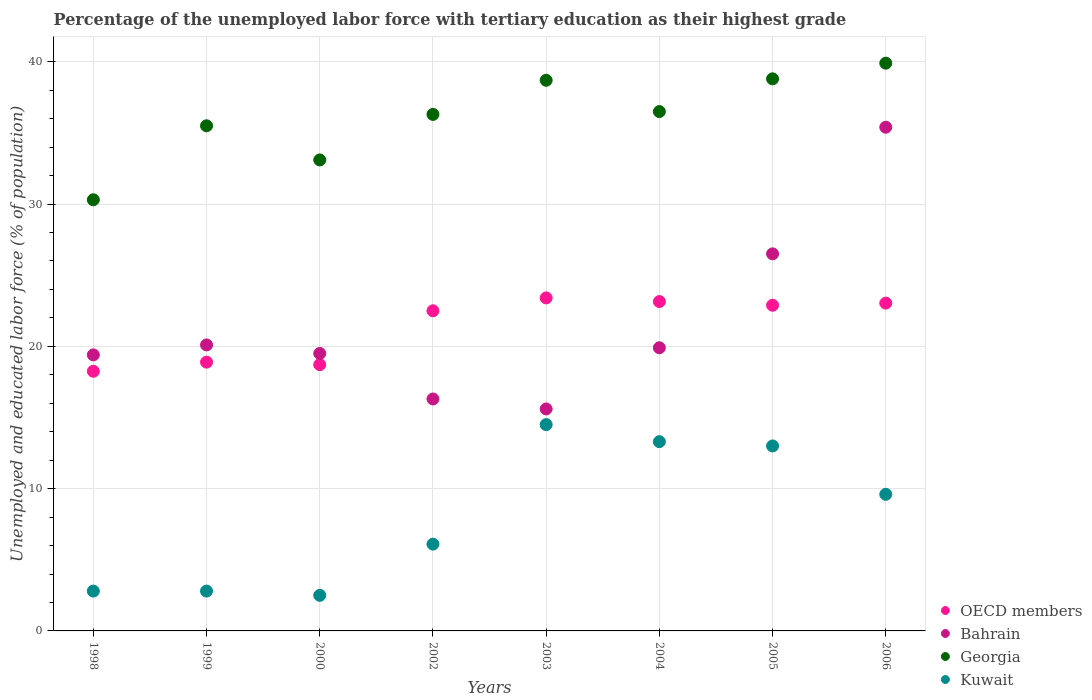How many different coloured dotlines are there?
Keep it short and to the point. 4. Is the number of dotlines equal to the number of legend labels?
Offer a very short reply. Yes. What is the percentage of the unemployed labor force with tertiary education in Georgia in 2005?
Provide a short and direct response. 38.8. Across all years, what is the maximum percentage of the unemployed labor force with tertiary education in Georgia?
Provide a short and direct response. 39.9. Across all years, what is the minimum percentage of the unemployed labor force with tertiary education in OECD members?
Ensure brevity in your answer.  18.25. In which year was the percentage of the unemployed labor force with tertiary education in Georgia minimum?
Your answer should be compact. 1998. What is the total percentage of the unemployed labor force with tertiary education in Georgia in the graph?
Keep it short and to the point. 289.1. What is the difference between the percentage of the unemployed labor force with tertiary education in Georgia in 2002 and that in 2006?
Ensure brevity in your answer.  -3.6. What is the difference between the percentage of the unemployed labor force with tertiary education in Georgia in 2003 and the percentage of the unemployed labor force with tertiary education in Bahrain in 1999?
Provide a succinct answer. 18.6. What is the average percentage of the unemployed labor force with tertiary education in Bahrain per year?
Offer a terse response. 21.59. In the year 2000, what is the difference between the percentage of the unemployed labor force with tertiary education in Kuwait and percentage of the unemployed labor force with tertiary education in Georgia?
Your answer should be compact. -30.6. In how many years, is the percentage of the unemployed labor force with tertiary education in Bahrain greater than 8 %?
Your response must be concise. 8. What is the ratio of the percentage of the unemployed labor force with tertiary education in Georgia in 1998 to that in 2002?
Your response must be concise. 0.83. Is the difference between the percentage of the unemployed labor force with tertiary education in Kuwait in 1998 and 2004 greater than the difference between the percentage of the unemployed labor force with tertiary education in Georgia in 1998 and 2004?
Provide a short and direct response. No. What is the difference between the highest and the second highest percentage of the unemployed labor force with tertiary education in Georgia?
Offer a very short reply. 1.1. What is the difference between the highest and the lowest percentage of the unemployed labor force with tertiary education in Kuwait?
Your answer should be compact. 12. In how many years, is the percentage of the unemployed labor force with tertiary education in Bahrain greater than the average percentage of the unemployed labor force with tertiary education in Bahrain taken over all years?
Your answer should be very brief. 2. Is it the case that in every year, the sum of the percentage of the unemployed labor force with tertiary education in OECD members and percentage of the unemployed labor force with tertiary education in Kuwait  is greater than the sum of percentage of the unemployed labor force with tertiary education in Bahrain and percentage of the unemployed labor force with tertiary education in Georgia?
Provide a succinct answer. No. Is it the case that in every year, the sum of the percentage of the unemployed labor force with tertiary education in Georgia and percentage of the unemployed labor force with tertiary education in Kuwait  is greater than the percentage of the unemployed labor force with tertiary education in OECD members?
Offer a terse response. Yes. Does the percentage of the unemployed labor force with tertiary education in Georgia monotonically increase over the years?
Make the answer very short. No. Where does the legend appear in the graph?
Provide a short and direct response. Bottom right. How many legend labels are there?
Make the answer very short. 4. What is the title of the graph?
Your answer should be very brief. Percentage of the unemployed labor force with tertiary education as their highest grade. What is the label or title of the X-axis?
Offer a terse response. Years. What is the label or title of the Y-axis?
Ensure brevity in your answer.  Unemployed and educated labor force (% of population). What is the Unemployed and educated labor force (% of population) of OECD members in 1998?
Offer a terse response. 18.25. What is the Unemployed and educated labor force (% of population) of Bahrain in 1998?
Provide a succinct answer. 19.4. What is the Unemployed and educated labor force (% of population) of Georgia in 1998?
Offer a very short reply. 30.3. What is the Unemployed and educated labor force (% of population) of Kuwait in 1998?
Your response must be concise. 2.8. What is the Unemployed and educated labor force (% of population) of OECD members in 1999?
Offer a very short reply. 18.89. What is the Unemployed and educated labor force (% of population) in Bahrain in 1999?
Give a very brief answer. 20.1. What is the Unemployed and educated labor force (% of population) in Georgia in 1999?
Provide a succinct answer. 35.5. What is the Unemployed and educated labor force (% of population) in Kuwait in 1999?
Your response must be concise. 2.8. What is the Unemployed and educated labor force (% of population) in OECD members in 2000?
Offer a terse response. 18.71. What is the Unemployed and educated labor force (% of population) in Bahrain in 2000?
Offer a very short reply. 19.5. What is the Unemployed and educated labor force (% of population) in Georgia in 2000?
Provide a succinct answer. 33.1. What is the Unemployed and educated labor force (% of population) in OECD members in 2002?
Offer a very short reply. 22.5. What is the Unemployed and educated labor force (% of population) of Bahrain in 2002?
Your answer should be compact. 16.3. What is the Unemployed and educated labor force (% of population) of Georgia in 2002?
Give a very brief answer. 36.3. What is the Unemployed and educated labor force (% of population) of Kuwait in 2002?
Keep it short and to the point. 6.1. What is the Unemployed and educated labor force (% of population) of OECD members in 2003?
Keep it short and to the point. 23.4. What is the Unemployed and educated labor force (% of population) of Bahrain in 2003?
Provide a succinct answer. 15.6. What is the Unemployed and educated labor force (% of population) in Georgia in 2003?
Your response must be concise. 38.7. What is the Unemployed and educated labor force (% of population) of Kuwait in 2003?
Make the answer very short. 14.5. What is the Unemployed and educated labor force (% of population) of OECD members in 2004?
Keep it short and to the point. 23.15. What is the Unemployed and educated labor force (% of population) of Bahrain in 2004?
Your answer should be very brief. 19.9. What is the Unemployed and educated labor force (% of population) in Georgia in 2004?
Your answer should be very brief. 36.5. What is the Unemployed and educated labor force (% of population) of Kuwait in 2004?
Ensure brevity in your answer.  13.3. What is the Unemployed and educated labor force (% of population) of OECD members in 2005?
Your response must be concise. 22.89. What is the Unemployed and educated labor force (% of population) in Georgia in 2005?
Give a very brief answer. 38.8. What is the Unemployed and educated labor force (% of population) of Kuwait in 2005?
Give a very brief answer. 13. What is the Unemployed and educated labor force (% of population) in OECD members in 2006?
Provide a succinct answer. 23.04. What is the Unemployed and educated labor force (% of population) of Bahrain in 2006?
Your answer should be compact. 35.4. What is the Unemployed and educated labor force (% of population) in Georgia in 2006?
Ensure brevity in your answer.  39.9. What is the Unemployed and educated labor force (% of population) in Kuwait in 2006?
Your response must be concise. 9.6. Across all years, what is the maximum Unemployed and educated labor force (% of population) of OECD members?
Your answer should be compact. 23.4. Across all years, what is the maximum Unemployed and educated labor force (% of population) in Bahrain?
Ensure brevity in your answer.  35.4. Across all years, what is the maximum Unemployed and educated labor force (% of population) in Georgia?
Provide a succinct answer. 39.9. Across all years, what is the maximum Unemployed and educated labor force (% of population) of Kuwait?
Make the answer very short. 14.5. Across all years, what is the minimum Unemployed and educated labor force (% of population) of OECD members?
Your answer should be very brief. 18.25. Across all years, what is the minimum Unemployed and educated labor force (% of population) in Bahrain?
Your response must be concise. 15.6. Across all years, what is the minimum Unemployed and educated labor force (% of population) of Georgia?
Give a very brief answer. 30.3. Across all years, what is the minimum Unemployed and educated labor force (% of population) in Kuwait?
Offer a very short reply. 2.5. What is the total Unemployed and educated labor force (% of population) of OECD members in the graph?
Offer a very short reply. 170.83. What is the total Unemployed and educated labor force (% of population) of Bahrain in the graph?
Offer a terse response. 172.7. What is the total Unemployed and educated labor force (% of population) of Georgia in the graph?
Keep it short and to the point. 289.1. What is the total Unemployed and educated labor force (% of population) in Kuwait in the graph?
Make the answer very short. 64.6. What is the difference between the Unemployed and educated labor force (% of population) in OECD members in 1998 and that in 1999?
Your response must be concise. -0.64. What is the difference between the Unemployed and educated labor force (% of population) in Bahrain in 1998 and that in 1999?
Provide a short and direct response. -0.7. What is the difference between the Unemployed and educated labor force (% of population) of Kuwait in 1998 and that in 1999?
Offer a terse response. 0. What is the difference between the Unemployed and educated labor force (% of population) in OECD members in 1998 and that in 2000?
Make the answer very short. -0.47. What is the difference between the Unemployed and educated labor force (% of population) in Bahrain in 1998 and that in 2000?
Your answer should be very brief. -0.1. What is the difference between the Unemployed and educated labor force (% of population) in OECD members in 1998 and that in 2002?
Keep it short and to the point. -4.25. What is the difference between the Unemployed and educated labor force (% of population) of Georgia in 1998 and that in 2002?
Ensure brevity in your answer.  -6. What is the difference between the Unemployed and educated labor force (% of population) of Kuwait in 1998 and that in 2002?
Your answer should be compact. -3.3. What is the difference between the Unemployed and educated labor force (% of population) of OECD members in 1998 and that in 2003?
Give a very brief answer. -5.16. What is the difference between the Unemployed and educated labor force (% of population) in Bahrain in 1998 and that in 2003?
Your response must be concise. 3.8. What is the difference between the Unemployed and educated labor force (% of population) in OECD members in 1998 and that in 2004?
Offer a very short reply. -4.9. What is the difference between the Unemployed and educated labor force (% of population) in Bahrain in 1998 and that in 2004?
Offer a very short reply. -0.5. What is the difference between the Unemployed and educated labor force (% of population) of OECD members in 1998 and that in 2005?
Provide a succinct answer. -4.64. What is the difference between the Unemployed and educated labor force (% of population) of Bahrain in 1998 and that in 2005?
Your response must be concise. -7.1. What is the difference between the Unemployed and educated labor force (% of population) of Georgia in 1998 and that in 2005?
Ensure brevity in your answer.  -8.5. What is the difference between the Unemployed and educated labor force (% of population) in Kuwait in 1998 and that in 2005?
Provide a succinct answer. -10.2. What is the difference between the Unemployed and educated labor force (% of population) in OECD members in 1998 and that in 2006?
Provide a succinct answer. -4.79. What is the difference between the Unemployed and educated labor force (% of population) in Georgia in 1998 and that in 2006?
Provide a short and direct response. -9.6. What is the difference between the Unemployed and educated labor force (% of population) in OECD members in 1999 and that in 2000?
Provide a short and direct response. 0.17. What is the difference between the Unemployed and educated labor force (% of population) in OECD members in 1999 and that in 2002?
Ensure brevity in your answer.  -3.61. What is the difference between the Unemployed and educated labor force (% of population) in Georgia in 1999 and that in 2002?
Keep it short and to the point. -0.8. What is the difference between the Unemployed and educated labor force (% of population) of OECD members in 1999 and that in 2003?
Offer a terse response. -4.51. What is the difference between the Unemployed and educated labor force (% of population) of OECD members in 1999 and that in 2004?
Provide a short and direct response. -4.26. What is the difference between the Unemployed and educated labor force (% of population) of Bahrain in 1999 and that in 2004?
Offer a very short reply. 0.2. What is the difference between the Unemployed and educated labor force (% of population) in OECD members in 1999 and that in 2005?
Make the answer very short. -4. What is the difference between the Unemployed and educated labor force (% of population) of Georgia in 1999 and that in 2005?
Your response must be concise. -3.3. What is the difference between the Unemployed and educated labor force (% of population) in OECD members in 1999 and that in 2006?
Offer a terse response. -4.15. What is the difference between the Unemployed and educated labor force (% of population) in Bahrain in 1999 and that in 2006?
Give a very brief answer. -15.3. What is the difference between the Unemployed and educated labor force (% of population) in Kuwait in 1999 and that in 2006?
Your answer should be very brief. -6.8. What is the difference between the Unemployed and educated labor force (% of population) in OECD members in 2000 and that in 2002?
Your answer should be very brief. -3.78. What is the difference between the Unemployed and educated labor force (% of population) in Georgia in 2000 and that in 2002?
Offer a terse response. -3.2. What is the difference between the Unemployed and educated labor force (% of population) in OECD members in 2000 and that in 2003?
Keep it short and to the point. -4.69. What is the difference between the Unemployed and educated labor force (% of population) in Georgia in 2000 and that in 2003?
Provide a short and direct response. -5.6. What is the difference between the Unemployed and educated labor force (% of population) of OECD members in 2000 and that in 2004?
Provide a short and direct response. -4.43. What is the difference between the Unemployed and educated labor force (% of population) of Kuwait in 2000 and that in 2004?
Ensure brevity in your answer.  -10.8. What is the difference between the Unemployed and educated labor force (% of population) in OECD members in 2000 and that in 2005?
Provide a short and direct response. -4.17. What is the difference between the Unemployed and educated labor force (% of population) of Bahrain in 2000 and that in 2005?
Keep it short and to the point. -7. What is the difference between the Unemployed and educated labor force (% of population) in Kuwait in 2000 and that in 2005?
Your answer should be very brief. -10.5. What is the difference between the Unemployed and educated labor force (% of population) of OECD members in 2000 and that in 2006?
Keep it short and to the point. -4.32. What is the difference between the Unemployed and educated labor force (% of population) in Bahrain in 2000 and that in 2006?
Ensure brevity in your answer.  -15.9. What is the difference between the Unemployed and educated labor force (% of population) of Georgia in 2000 and that in 2006?
Offer a very short reply. -6.8. What is the difference between the Unemployed and educated labor force (% of population) in Kuwait in 2000 and that in 2006?
Make the answer very short. -7.1. What is the difference between the Unemployed and educated labor force (% of population) in OECD members in 2002 and that in 2003?
Offer a terse response. -0.91. What is the difference between the Unemployed and educated labor force (% of population) of Bahrain in 2002 and that in 2003?
Make the answer very short. 0.7. What is the difference between the Unemployed and educated labor force (% of population) of Georgia in 2002 and that in 2003?
Offer a very short reply. -2.4. What is the difference between the Unemployed and educated labor force (% of population) in OECD members in 2002 and that in 2004?
Your answer should be very brief. -0.65. What is the difference between the Unemployed and educated labor force (% of population) of Bahrain in 2002 and that in 2004?
Your response must be concise. -3.6. What is the difference between the Unemployed and educated labor force (% of population) of Kuwait in 2002 and that in 2004?
Your answer should be very brief. -7.2. What is the difference between the Unemployed and educated labor force (% of population) of OECD members in 2002 and that in 2005?
Your answer should be compact. -0.39. What is the difference between the Unemployed and educated labor force (% of population) of Bahrain in 2002 and that in 2005?
Ensure brevity in your answer.  -10.2. What is the difference between the Unemployed and educated labor force (% of population) of Kuwait in 2002 and that in 2005?
Provide a succinct answer. -6.9. What is the difference between the Unemployed and educated labor force (% of population) of OECD members in 2002 and that in 2006?
Offer a very short reply. -0.54. What is the difference between the Unemployed and educated labor force (% of population) in Bahrain in 2002 and that in 2006?
Offer a very short reply. -19.1. What is the difference between the Unemployed and educated labor force (% of population) in OECD members in 2003 and that in 2004?
Your response must be concise. 0.26. What is the difference between the Unemployed and educated labor force (% of population) in Bahrain in 2003 and that in 2004?
Keep it short and to the point. -4.3. What is the difference between the Unemployed and educated labor force (% of population) in Georgia in 2003 and that in 2004?
Offer a very short reply. 2.2. What is the difference between the Unemployed and educated labor force (% of population) in Kuwait in 2003 and that in 2004?
Provide a short and direct response. 1.2. What is the difference between the Unemployed and educated labor force (% of population) of OECD members in 2003 and that in 2005?
Your answer should be compact. 0.52. What is the difference between the Unemployed and educated labor force (% of population) of Kuwait in 2003 and that in 2005?
Provide a succinct answer. 1.5. What is the difference between the Unemployed and educated labor force (% of population) in OECD members in 2003 and that in 2006?
Your answer should be compact. 0.37. What is the difference between the Unemployed and educated labor force (% of population) of Bahrain in 2003 and that in 2006?
Ensure brevity in your answer.  -19.8. What is the difference between the Unemployed and educated labor force (% of population) of OECD members in 2004 and that in 2005?
Give a very brief answer. 0.26. What is the difference between the Unemployed and educated labor force (% of population) in Georgia in 2004 and that in 2005?
Provide a short and direct response. -2.3. What is the difference between the Unemployed and educated labor force (% of population) of OECD members in 2004 and that in 2006?
Your answer should be compact. 0.11. What is the difference between the Unemployed and educated labor force (% of population) of Bahrain in 2004 and that in 2006?
Your answer should be compact. -15.5. What is the difference between the Unemployed and educated labor force (% of population) in OECD members in 2005 and that in 2006?
Make the answer very short. -0.15. What is the difference between the Unemployed and educated labor force (% of population) of Bahrain in 2005 and that in 2006?
Give a very brief answer. -8.9. What is the difference between the Unemployed and educated labor force (% of population) of Georgia in 2005 and that in 2006?
Provide a succinct answer. -1.1. What is the difference between the Unemployed and educated labor force (% of population) of OECD members in 1998 and the Unemployed and educated labor force (% of population) of Bahrain in 1999?
Your answer should be very brief. -1.85. What is the difference between the Unemployed and educated labor force (% of population) of OECD members in 1998 and the Unemployed and educated labor force (% of population) of Georgia in 1999?
Keep it short and to the point. -17.25. What is the difference between the Unemployed and educated labor force (% of population) in OECD members in 1998 and the Unemployed and educated labor force (% of population) in Kuwait in 1999?
Offer a terse response. 15.45. What is the difference between the Unemployed and educated labor force (% of population) in Bahrain in 1998 and the Unemployed and educated labor force (% of population) in Georgia in 1999?
Your answer should be compact. -16.1. What is the difference between the Unemployed and educated labor force (% of population) in OECD members in 1998 and the Unemployed and educated labor force (% of population) in Bahrain in 2000?
Make the answer very short. -1.25. What is the difference between the Unemployed and educated labor force (% of population) of OECD members in 1998 and the Unemployed and educated labor force (% of population) of Georgia in 2000?
Your response must be concise. -14.85. What is the difference between the Unemployed and educated labor force (% of population) of OECD members in 1998 and the Unemployed and educated labor force (% of population) of Kuwait in 2000?
Keep it short and to the point. 15.75. What is the difference between the Unemployed and educated labor force (% of population) of Bahrain in 1998 and the Unemployed and educated labor force (% of population) of Georgia in 2000?
Provide a short and direct response. -13.7. What is the difference between the Unemployed and educated labor force (% of population) of Georgia in 1998 and the Unemployed and educated labor force (% of population) of Kuwait in 2000?
Offer a very short reply. 27.8. What is the difference between the Unemployed and educated labor force (% of population) of OECD members in 1998 and the Unemployed and educated labor force (% of population) of Bahrain in 2002?
Make the answer very short. 1.95. What is the difference between the Unemployed and educated labor force (% of population) of OECD members in 1998 and the Unemployed and educated labor force (% of population) of Georgia in 2002?
Ensure brevity in your answer.  -18.05. What is the difference between the Unemployed and educated labor force (% of population) in OECD members in 1998 and the Unemployed and educated labor force (% of population) in Kuwait in 2002?
Keep it short and to the point. 12.15. What is the difference between the Unemployed and educated labor force (% of population) of Bahrain in 1998 and the Unemployed and educated labor force (% of population) of Georgia in 2002?
Provide a short and direct response. -16.9. What is the difference between the Unemployed and educated labor force (% of population) in Georgia in 1998 and the Unemployed and educated labor force (% of population) in Kuwait in 2002?
Offer a terse response. 24.2. What is the difference between the Unemployed and educated labor force (% of population) in OECD members in 1998 and the Unemployed and educated labor force (% of population) in Bahrain in 2003?
Your response must be concise. 2.65. What is the difference between the Unemployed and educated labor force (% of population) in OECD members in 1998 and the Unemployed and educated labor force (% of population) in Georgia in 2003?
Keep it short and to the point. -20.45. What is the difference between the Unemployed and educated labor force (% of population) of OECD members in 1998 and the Unemployed and educated labor force (% of population) of Kuwait in 2003?
Give a very brief answer. 3.75. What is the difference between the Unemployed and educated labor force (% of population) in Bahrain in 1998 and the Unemployed and educated labor force (% of population) in Georgia in 2003?
Give a very brief answer. -19.3. What is the difference between the Unemployed and educated labor force (% of population) of OECD members in 1998 and the Unemployed and educated labor force (% of population) of Bahrain in 2004?
Your response must be concise. -1.65. What is the difference between the Unemployed and educated labor force (% of population) of OECD members in 1998 and the Unemployed and educated labor force (% of population) of Georgia in 2004?
Provide a succinct answer. -18.25. What is the difference between the Unemployed and educated labor force (% of population) in OECD members in 1998 and the Unemployed and educated labor force (% of population) in Kuwait in 2004?
Give a very brief answer. 4.95. What is the difference between the Unemployed and educated labor force (% of population) of Bahrain in 1998 and the Unemployed and educated labor force (% of population) of Georgia in 2004?
Offer a very short reply. -17.1. What is the difference between the Unemployed and educated labor force (% of population) of Bahrain in 1998 and the Unemployed and educated labor force (% of population) of Kuwait in 2004?
Make the answer very short. 6.1. What is the difference between the Unemployed and educated labor force (% of population) in Georgia in 1998 and the Unemployed and educated labor force (% of population) in Kuwait in 2004?
Make the answer very short. 17. What is the difference between the Unemployed and educated labor force (% of population) in OECD members in 1998 and the Unemployed and educated labor force (% of population) in Bahrain in 2005?
Offer a very short reply. -8.25. What is the difference between the Unemployed and educated labor force (% of population) of OECD members in 1998 and the Unemployed and educated labor force (% of population) of Georgia in 2005?
Offer a very short reply. -20.55. What is the difference between the Unemployed and educated labor force (% of population) of OECD members in 1998 and the Unemployed and educated labor force (% of population) of Kuwait in 2005?
Offer a very short reply. 5.25. What is the difference between the Unemployed and educated labor force (% of population) in Bahrain in 1998 and the Unemployed and educated labor force (% of population) in Georgia in 2005?
Your answer should be compact. -19.4. What is the difference between the Unemployed and educated labor force (% of population) in OECD members in 1998 and the Unemployed and educated labor force (% of population) in Bahrain in 2006?
Your response must be concise. -17.15. What is the difference between the Unemployed and educated labor force (% of population) of OECD members in 1998 and the Unemployed and educated labor force (% of population) of Georgia in 2006?
Your answer should be very brief. -21.65. What is the difference between the Unemployed and educated labor force (% of population) of OECD members in 1998 and the Unemployed and educated labor force (% of population) of Kuwait in 2006?
Your answer should be very brief. 8.65. What is the difference between the Unemployed and educated labor force (% of population) of Bahrain in 1998 and the Unemployed and educated labor force (% of population) of Georgia in 2006?
Offer a terse response. -20.5. What is the difference between the Unemployed and educated labor force (% of population) in Georgia in 1998 and the Unemployed and educated labor force (% of population) in Kuwait in 2006?
Keep it short and to the point. 20.7. What is the difference between the Unemployed and educated labor force (% of population) of OECD members in 1999 and the Unemployed and educated labor force (% of population) of Bahrain in 2000?
Offer a terse response. -0.61. What is the difference between the Unemployed and educated labor force (% of population) in OECD members in 1999 and the Unemployed and educated labor force (% of population) in Georgia in 2000?
Your answer should be compact. -14.21. What is the difference between the Unemployed and educated labor force (% of population) in OECD members in 1999 and the Unemployed and educated labor force (% of population) in Kuwait in 2000?
Offer a terse response. 16.39. What is the difference between the Unemployed and educated labor force (% of population) of Georgia in 1999 and the Unemployed and educated labor force (% of population) of Kuwait in 2000?
Your response must be concise. 33. What is the difference between the Unemployed and educated labor force (% of population) of OECD members in 1999 and the Unemployed and educated labor force (% of population) of Bahrain in 2002?
Ensure brevity in your answer.  2.59. What is the difference between the Unemployed and educated labor force (% of population) in OECD members in 1999 and the Unemployed and educated labor force (% of population) in Georgia in 2002?
Your answer should be very brief. -17.41. What is the difference between the Unemployed and educated labor force (% of population) of OECD members in 1999 and the Unemployed and educated labor force (% of population) of Kuwait in 2002?
Provide a succinct answer. 12.79. What is the difference between the Unemployed and educated labor force (% of population) of Bahrain in 1999 and the Unemployed and educated labor force (% of population) of Georgia in 2002?
Offer a very short reply. -16.2. What is the difference between the Unemployed and educated labor force (% of population) in Georgia in 1999 and the Unemployed and educated labor force (% of population) in Kuwait in 2002?
Your answer should be compact. 29.4. What is the difference between the Unemployed and educated labor force (% of population) of OECD members in 1999 and the Unemployed and educated labor force (% of population) of Bahrain in 2003?
Your answer should be compact. 3.29. What is the difference between the Unemployed and educated labor force (% of population) of OECD members in 1999 and the Unemployed and educated labor force (% of population) of Georgia in 2003?
Provide a short and direct response. -19.81. What is the difference between the Unemployed and educated labor force (% of population) in OECD members in 1999 and the Unemployed and educated labor force (% of population) in Kuwait in 2003?
Offer a very short reply. 4.39. What is the difference between the Unemployed and educated labor force (% of population) of Bahrain in 1999 and the Unemployed and educated labor force (% of population) of Georgia in 2003?
Make the answer very short. -18.6. What is the difference between the Unemployed and educated labor force (% of population) in Bahrain in 1999 and the Unemployed and educated labor force (% of population) in Kuwait in 2003?
Make the answer very short. 5.6. What is the difference between the Unemployed and educated labor force (% of population) in OECD members in 1999 and the Unemployed and educated labor force (% of population) in Bahrain in 2004?
Your answer should be very brief. -1.01. What is the difference between the Unemployed and educated labor force (% of population) of OECD members in 1999 and the Unemployed and educated labor force (% of population) of Georgia in 2004?
Provide a succinct answer. -17.61. What is the difference between the Unemployed and educated labor force (% of population) of OECD members in 1999 and the Unemployed and educated labor force (% of population) of Kuwait in 2004?
Provide a short and direct response. 5.59. What is the difference between the Unemployed and educated labor force (% of population) of Bahrain in 1999 and the Unemployed and educated labor force (% of population) of Georgia in 2004?
Provide a short and direct response. -16.4. What is the difference between the Unemployed and educated labor force (% of population) in OECD members in 1999 and the Unemployed and educated labor force (% of population) in Bahrain in 2005?
Offer a very short reply. -7.61. What is the difference between the Unemployed and educated labor force (% of population) of OECD members in 1999 and the Unemployed and educated labor force (% of population) of Georgia in 2005?
Provide a succinct answer. -19.91. What is the difference between the Unemployed and educated labor force (% of population) of OECD members in 1999 and the Unemployed and educated labor force (% of population) of Kuwait in 2005?
Your response must be concise. 5.89. What is the difference between the Unemployed and educated labor force (% of population) of Bahrain in 1999 and the Unemployed and educated labor force (% of population) of Georgia in 2005?
Make the answer very short. -18.7. What is the difference between the Unemployed and educated labor force (% of population) in OECD members in 1999 and the Unemployed and educated labor force (% of population) in Bahrain in 2006?
Your answer should be compact. -16.51. What is the difference between the Unemployed and educated labor force (% of population) of OECD members in 1999 and the Unemployed and educated labor force (% of population) of Georgia in 2006?
Give a very brief answer. -21.01. What is the difference between the Unemployed and educated labor force (% of population) of OECD members in 1999 and the Unemployed and educated labor force (% of population) of Kuwait in 2006?
Keep it short and to the point. 9.29. What is the difference between the Unemployed and educated labor force (% of population) in Bahrain in 1999 and the Unemployed and educated labor force (% of population) in Georgia in 2006?
Your response must be concise. -19.8. What is the difference between the Unemployed and educated labor force (% of population) in Georgia in 1999 and the Unemployed and educated labor force (% of population) in Kuwait in 2006?
Your response must be concise. 25.9. What is the difference between the Unemployed and educated labor force (% of population) in OECD members in 2000 and the Unemployed and educated labor force (% of population) in Bahrain in 2002?
Make the answer very short. 2.41. What is the difference between the Unemployed and educated labor force (% of population) in OECD members in 2000 and the Unemployed and educated labor force (% of population) in Georgia in 2002?
Provide a short and direct response. -17.59. What is the difference between the Unemployed and educated labor force (% of population) in OECD members in 2000 and the Unemployed and educated labor force (% of population) in Kuwait in 2002?
Make the answer very short. 12.61. What is the difference between the Unemployed and educated labor force (% of population) in Bahrain in 2000 and the Unemployed and educated labor force (% of population) in Georgia in 2002?
Ensure brevity in your answer.  -16.8. What is the difference between the Unemployed and educated labor force (% of population) in Bahrain in 2000 and the Unemployed and educated labor force (% of population) in Kuwait in 2002?
Your answer should be compact. 13.4. What is the difference between the Unemployed and educated labor force (% of population) of OECD members in 2000 and the Unemployed and educated labor force (% of population) of Bahrain in 2003?
Keep it short and to the point. 3.11. What is the difference between the Unemployed and educated labor force (% of population) of OECD members in 2000 and the Unemployed and educated labor force (% of population) of Georgia in 2003?
Your answer should be very brief. -19.99. What is the difference between the Unemployed and educated labor force (% of population) of OECD members in 2000 and the Unemployed and educated labor force (% of population) of Kuwait in 2003?
Your answer should be very brief. 4.21. What is the difference between the Unemployed and educated labor force (% of population) in Bahrain in 2000 and the Unemployed and educated labor force (% of population) in Georgia in 2003?
Offer a terse response. -19.2. What is the difference between the Unemployed and educated labor force (% of population) in Georgia in 2000 and the Unemployed and educated labor force (% of population) in Kuwait in 2003?
Offer a very short reply. 18.6. What is the difference between the Unemployed and educated labor force (% of population) of OECD members in 2000 and the Unemployed and educated labor force (% of population) of Bahrain in 2004?
Give a very brief answer. -1.19. What is the difference between the Unemployed and educated labor force (% of population) in OECD members in 2000 and the Unemployed and educated labor force (% of population) in Georgia in 2004?
Make the answer very short. -17.79. What is the difference between the Unemployed and educated labor force (% of population) in OECD members in 2000 and the Unemployed and educated labor force (% of population) in Kuwait in 2004?
Keep it short and to the point. 5.41. What is the difference between the Unemployed and educated labor force (% of population) in Bahrain in 2000 and the Unemployed and educated labor force (% of population) in Kuwait in 2004?
Offer a terse response. 6.2. What is the difference between the Unemployed and educated labor force (% of population) in Georgia in 2000 and the Unemployed and educated labor force (% of population) in Kuwait in 2004?
Ensure brevity in your answer.  19.8. What is the difference between the Unemployed and educated labor force (% of population) in OECD members in 2000 and the Unemployed and educated labor force (% of population) in Bahrain in 2005?
Make the answer very short. -7.79. What is the difference between the Unemployed and educated labor force (% of population) in OECD members in 2000 and the Unemployed and educated labor force (% of population) in Georgia in 2005?
Keep it short and to the point. -20.09. What is the difference between the Unemployed and educated labor force (% of population) of OECD members in 2000 and the Unemployed and educated labor force (% of population) of Kuwait in 2005?
Give a very brief answer. 5.71. What is the difference between the Unemployed and educated labor force (% of population) of Bahrain in 2000 and the Unemployed and educated labor force (% of population) of Georgia in 2005?
Your answer should be compact. -19.3. What is the difference between the Unemployed and educated labor force (% of population) in Georgia in 2000 and the Unemployed and educated labor force (% of population) in Kuwait in 2005?
Offer a terse response. 20.1. What is the difference between the Unemployed and educated labor force (% of population) in OECD members in 2000 and the Unemployed and educated labor force (% of population) in Bahrain in 2006?
Give a very brief answer. -16.69. What is the difference between the Unemployed and educated labor force (% of population) of OECD members in 2000 and the Unemployed and educated labor force (% of population) of Georgia in 2006?
Provide a short and direct response. -21.19. What is the difference between the Unemployed and educated labor force (% of population) of OECD members in 2000 and the Unemployed and educated labor force (% of population) of Kuwait in 2006?
Your answer should be very brief. 9.11. What is the difference between the Unemployed and educated labor force (% of population) of Bahrain in 2000 and the Unemployed and educated labor force (% of population) of Georgia in 2006?
Keep it short and to the point. -20.4. What is the difference between the Unemployed and educated labor force (% of population) in Georgia in 2000 and the Unemployed and educated labor force (% of population) in Kuwait in 2006?
Offer a very short reply. 23.5. What is the difference between the Unemployed and educated labor force (% of population) of OECD members in 2002 and the Unemployed and educated labor force (% of population) of Bahrain in 2003?
Provide a succinct answer. 6.9. What is the difference between the Unemployed and educated labor force (% of population) of OECD members in 2002 and the Unemployed and educated labor force (% of population) of Georgia in 2003?
Offer a very short reply. -16.2. What is the difference between the Unemployed and educated labor force (% of population) in OECD members in 2002 and the Unemployed and educated labor force (% of population) in Kuwait in 2003?
Your answer should be very brief. 8. What is the difference between the Unemployed and educated labor force (% of population) in Bahrain in 2002 and the Unemployed and educated labor force (% of population) in Georgia in 2003?
Your answer should be very brief. -22.4. What is the difference between the Unemployed and educated labor force (% of population) in Georgia in 2002 and the Unemployed and educated labor force (% of population) in Kuwait in 2003?
Keep it short and to the point. 21.8. What is the difference between the Unemployed and educated labor force (% of population) in OECD members in 2002 and the Unemployed and educated labor force (% of population) in Bahrain in 2004?
Offer a very short reply. 2.6. What is the difference between the Unemployed and educated labor force (% of population) of OECD members in 2002 and the Unemployed and educated labor force (% of population) of Georgia in 2004?
Your answer should be compact. -14. What is the difference between the Unemployed and educated labor force (% of population) of OECD members in 2002 and the Unemployed and educated labor force (% of population) of Kuwait in 2004?
Your answer should be very brief. 9.2. What is the difference between the Unemployed and educated labor force (% of population) in Bahrain in 2002 and the Unemployed and educated labor force (% of population) in Georgia in 2004?
Your answer should be very brief. -20.2. What is the difference between the Unemployed and educated labor force (% of population) in Bahrain in 2002 and the Unemployed and educated labor force (% of population) in Kuwait in 2004?
Provide a succinct answer. 3. What is the difference between the Unemployed and educated labor force (% of population) of Georgia in 2002 and the Unemployed and educated labor force (% of population) of Kuwait in 2004?
Provide a succinct answer. 23. What is the difference between the Unemployed and educated labor force (% of population) of OECD members in 2002 and the Unemployed and educated labor force (% of population) of Bahrain in 2005?
Make the answer very short. -4. What is the difference between the Unemployed and educated labor force (% of population) of OECD members in 2002 and the Unemployed and educated labor force (% of population) of Georgia in 2005?
Your answer should be very brief. -16.3. What is the difference between the Unemployed and educated labor force (% of population) of OECD members in 2002 and the Unemployed and educated labor force (% of population) of Kuwait in 2005?
Ensure brevity in your answer.  9.5. What is the difference between the Unemployed and educated labor force (% of population) in Bahrain in 2002 and the Unemployed and educated labor force (% of population) in Georgia in 2005?
Offer a very short reply. -22.5. What is the difference between the Unemployed and educated labor force (% of population) of Georgia in 2002 and the Unemployed and educated labor force (% of population) of Kuwait in 2005?
Offer a terse response. 23.3. What is the difference between the Unemployed and educated labor force (% of population) of OECD members in 2002 and the Unemployed and educated labor force (% of population) of Bahrain in 2006?
Your response must be concise. -12.9. What is the difference between the Unemployed and educated labor force (% of population) in OECD members in 2002 and the Unemployed and educated labor force (% of population) in Georgia in 2006?
Your answer should be very brief. -17.4. What is the difference between the Unemployed and educated labor force (% of population) in OECD members in 2002 and the Unemployed and educated labor force (% of population) in Kuwait in 2006?
Provide a short and direct response. 12.9. What is the difference between the Unemployed and educated labor force (% of population) of Bahrain in 2002 and the Unemployed and educated labor force (% of population) of Georgia in 2006?
Make the answer very short. -23.6. What is the difference between the Unemployed and educated labor force (% of population) in Bahrain in 2002 and the Unemployed and educated labor force (% of population) in Kuwait in 2006?
Offer a terse response. 6.7. What is the difference between the Unemployed and educated labor force (% of population) of Georgia in 2002 and the Unemployed and educated labor force (% of population) of Kuwait in 2006?
Give a very brief answer. 26.7. What is the difference between the Unemployed and educated labor force (% of population) of OECD members in 2003 and the Unemployed and educated labor force (% of population) of Bahrain in 2004?
Ensure brevity in your answer.  3.5. What is the difference between the Unemployed and educated labor force (% of population) in OECD members in 2003 and the Unemployed and educated labor force (% of population) in Georgia in 2004?
Ensure brevity in your answer.  -13.1. What is the difference between the Unemployed and educated labor force (% of population) in OECD members in 2003 and the Unemployed and educated labor force (% of population) in Kuwait in 2004?
Provide a short and direct response. 10.1. What is the difference between the Unemployed and educated labor force (% of population) of Bahrain in 2003 and the Unemployed and educated labor force (% of population) of Georgia in 2004?
Keep it short and to the point. -20.9. What is the difference between the Unemployed and educated labor force (% of population) of Bahrain in 2003 and the Unemployed and educated labor force (% of population) of Kuwait in 2004?
Ensure brevity in your answer.  2.3. What is the difference between the Unemployed and educated labor force (% of population) of Georgia in 2003 and the Unemployed and educated labor force (% of population) of Kuwait in 2004?
Provide a succinct answer. 25.4. What is the difference between the Unemployed and educated labor force (% of population) in OECD members in 2003 and the Unemployed and educated labor force (% of population) in Bahrain in 2005?
Make the answer very short. -3.1. What is the difference between the Unemployed and educated labor force (% of population) in OECD members in 2003 and the Unemployed and educated labor force (% of population) in Georgia in 2005?
Give a very brief answer. -15.4. What is the difference between the Unemployed and educated labor force (% of population) in OECD members in 2003 and the Unemployed and educated labor force (% of population) in Kuwait in 2005?
Your answer should be compact. 10.4. What is the difference between the Unemployed and educated labor force (% of population) in Bahrain in 2003 and the Unemployed and educated labor force (% of population) in Georgia in 2005?
Give a very brief answer. -23.2. What is the difference between the Unemployed and educated labor force (% of population) in Bahrain in 2003 and the Unemployed and educated labor force (% of population) in Kuwait in 2005?
Offer a very short reply. 2.6. What is the difference between the Unemployed and educated labor force (% of population) of Georgia in 2003 and the Unemployed and educated labor force (% of population) of Kuwait in 2005?
Your answer should be compact. 25.7. What is the difference between the Unemployed and educated labor force (% of population) in OECD members in 2003 and the Unemployed and educated labor force (% of population) in Bahrain in 2006?
Your response must be concise. -12. What is the difference between the Unemployed and educated labor force (% of population) in OECD members in 2003 and the Unemployed and educated labor force (% of population) in Georgia in 2006?
Your answer should be compact. -16.5. What is the difference between the Unemployed and educated labor force (% of population) in OECD members in 2003 and the Unemployed and educated labor force (% of population) in Kuwait in 2006?
Provide a succinct answer. 13.8. What is the difference between the Unemployed and educated labor force (% of population) of Bahrain in 2003 and the Unemployed and educated labor force (% of population) of Georgia in 2006?
Provide a succinct answer. -24.3. What is the difference between the Unemployed and educated labor force (% of population) in Georgia in 2003 and the Unemployed and educated labor force (% of population) in Kuwait in 2006?
Provide a succinct answer. 29.1. What is the difference between the Unemployed and educated labor force (% of population) in OECD members in 2004 and the Unemployed and educated labor force (% of population) in Bahrain in 2005?
Give a very brief answer. -3.35. What is the difference between the Unemployed and educated labor force (% of population) in OECD members in 2004 and the Unemployed and educated labor force (% of population) in Georgia in 2005?
Your answer should be compact. -15.65. What is the difference between the Unemployed and educated labor force (% of population) of OECD members in 2004 and the Unemployed and educated labor force (% of population) of Kuwait in 2005?
Provide a succinct answer. 10.15. What is the difference between the Unemployed and educated labor force (% of population) in Bahrain in 2004 and the Unemployed and educated labor force (% of population) in Georgia in 2005?
Provide a succinct answer. -18.9. What is the difference between the Unemployed and educated labor force (% of population) in Bahrain in 2004 and the Unemployed and educated labor force (% of population) in Kuwait in 2005?
Provide a short and direct response. 6.9. What is the difference between the Unemployed and educated labor force (% of population) of Georgia in 2004 and the Unemployed and educated labor force (% of population) of Kuwait in 2005?
Offer a very short reply. 23.5. What is the difference between the Unemployed and educated labor force (% of population) of OECD members in 2004 and the Unemployed and educated labor force (% of population) of Bahrain in 2006?
Your response must be concise. -12.25. What is the difference between the Unemployed and educated labor force (% of population) of OECD members in 2004 and the Unemployed and educated labor force (% of population) of Georgia in 2006?
Ensure brevity in your answer.  -16.75. What is the difference between the Unemployed and educated labor force (% of population) in OECD members in 2004 and the Unemployed and educated labor force (% of population) in Kuwait in 2006?
Make the answer very short. 13.55. What is the difference between the Unemployed and educated labor force (% of population) in Bahrain in 2004 and the Unemployed and educated labor force (% of population) in Georgia in 2006?
Your answer should be very brief. -20. What is the difference between the Unemployed and educated labor force (% of population) in Georgia in 2004 and the Unemployed and educated labor force (% of population) in Kuwait in 2006?
Provide a succinct answer. 26.9. What is the difference between the Unemployed and educated labor force (% of population) of OECD members in 2005 and the Unemployed and educated labor force (% of population) of Bahrain in 2006?
Make the answer very short. -12.51. What is the difference between the Unemployed and educated labor force (% of population) in OECD members in 2005 and the Unemployed and educated labor force (% of population) in Georgia in 2006?
Your answer should be very brief. -17.01. What is the difference between the Unemployed and educated labor force (% of population) in OECD members in 2005 and the Unemployed and educated labor force (% of population) in Kuwait in 2006?
Your answer should be very brief. 13.29. What is the difference between the Unemployed and educated labor force (% of population) of Georgia in 2005 and the Unemployed and educated labor force (% of population) of Kuwait in 2006?
Offer a very short reply. 29.2. What is the average Unemployed and educated labor force (% of population) of OECD members per year?
Offer a very short reply. 21.35. What is the average Unemployed and educated labor force (% of population) in Bahrain per year?
Provide a short and direct response. 21.59. What is the average Unemployed and educated labor force (% of population) in Georgia per year?
Keep it short and to the point. 36.14. What is the average Unemployed and educated labor force (% of population) in Kuwait per year?
Offer a terse response. 8.07. In the year 1998, what is the difference between the Unemployed and educated labor force (% of population) of OECD members and Unemployed and educated labor force (% of population) of Bahrain?
Offer a very short reply. -1.15. In the year 1998, what is the difference between the Unemployed and educated labor force (% of population) of OECD members and Unemployed and educated labor force (% of population) of Georgia?
Your response must be concise. -12.05. In the year 1998, what is the difference between the Unemployed and educated labor force (% of population) in OECD members and Unemployed and educated labor force (% of population) in Kuwait?
Ensure brevity in your answer.  15.45. In the year 1998, what is the difference between the Unemployed and educated labor force (% of population) in Bahrain and Unemployed and educated labor force (% of population) in Georgia?
Provide a short and direct response. -10.9. In the year 1999, what is the difference between the Unemployed and educated labor force (% of population) of OECD members and Unemployed and educated labor force (% of population) of Bahrain?
Offer a very short reply. -1.21. In the year 1999, what is the difference between the Unemployed and educated labor force (% of population) of OECD members and Unemployed and educated labor force (% of population) of Georgia?
Ensure brevity in your answer.  -16.61. In the year 1999, what is the difference between the Unemployed and educated labor force (% of population) in OECD members and Unemployed and educated labor force (% of population) in Kuwait?
Give a very brief answer. 16.09. In the year 1999, what is the difference between the Unemployed and educated labor force (% of population) in Bahrain and Unemployed and educated labor force (% of population) in Georgia?
Your answer should be very brief. -15.4. In the year 1999, what is the difference between the Unemployed and educated labor force (% of population) in Georgia and Unemployed and educated labor force (% of population) in Kuwait?
Give a very brief answer. 32.7. In the year 2000, what is the difference between the Unemployed and educated labor force (% of population) of OECD members and Unemployed and educated labor force (% of population) of Bahrain?
Keep it short and to the point. -0.79. In the year 2000, what is the difference between the Unemployed and educated labor force (% of population) of OECD members and Unemployed and educated labor force (% of population) of Georgia?
Provide a short and direct response. -14.39. In the year 2000, what is the difference between the Unemployed and educated labor force (% of population) of OECD members and Unemployed and educated labor force (% of population) of Kuwait?
Provide a succinct answer. 16.21. In the year 2000, what is the difference between the Unemployed and educated labor force (% of population) in Georgia and Unemployed and educated labor force (% of population) in Kuwait?
Offer a terse response. 30.6. In the year 2002, what is the difference between the Unemployed and educated labor force (% of population) in OECD members and Unemployed and educated labor force (% of population) in Bahrain?
Offer a very short reply. 6.2. In the year 2002, what is the difference between the Unemployed and educated labor force (% of population) in OECD members and Unemployed and educated labor force (% of population) in Georgia?
Give a very brief answer. -13.8. In the year 2002, what is the difference between the Unemployed and educated labor force (% of population) in OECD members and Unemployed and educated labor force (% of population) in Kuwait?
Your answer should be compact. 16.4. In the year 2002, what is the difference between the Unemployed and educated labor force (% of population) of Bahrain and Unemployed and educated labor force (% of population) of Kuwait?
Keep it short and to the point. 10.2. In the year 2002, what is the difference between the Unemployed and educated labor force (% of population) of Georgia and Unemployed and educated labor force (% of population) of Kuwait?
Offer a very short reply. 30.2. In the year 2003, what is the difference between the Unemployed and educated labor force (% of population) in OECD members and Unemployed and educated labor force (% of population) in Bahrain?
Ensure brevity in your answer.  7.8. In the year 2003, what is the difference between the Unemployed and educated labor force (% of population) of OECD members and Unemployed and educated labor force (% of population) of Georgia?
Provide a succinct answer. -15.3. In the year 2003, what is the difference between the Unemployed and educated labor force (% of population) of OECD members and Unemployed and educated labor force (% of population) of Kuwait?
Your response must be concise. 8.9. In the year 2003, what is the difference between the Unemployed and educated labor force (% of population) in Bahrain and Unemployed and educated labor force (% of population) in Georgia?
Give a very brief answer. -23.1. In the year 2003, what is the difference between the Unemployed and educated labor force (% of population) in Georgia and Unemployed and educated labor force (% of population) in Kuwait?
Offer a very short reply. 24.2. In the year 2004, what is the difference between the Unemployed and educated labor force (% of population) in OECD members and Unemployed and educated labor force (% of population) in Bahrain?
Offer a very short reply. 3.25. In the year 2004, what is the difference between the Unemployed and educated labor force (% of population) of OECD members and Unemployed and educated labor force (% of population) of Georgia?
Offer a terse response. -13.35. In the year 2004, what is the difference between the Unemployed and educated labor force (% of population) of OECD members and Unemployed and educated labor force (% of population) of Kuwait?
Provide a succinct answer. 9.85. In the year 2004, what is the difference between the Unemployed and educated labor force (% of population) of Bahrain and Unemployed and educated labor force (% of population) of Georgia?
Provide a succinct answer. -16.6. In the year 2004, what is the difference between the Unemployed and educated labor force (% of population) in Georgia and Unemployed and educated labor force (% of population) in Kuwait?
Provide a short and direct response. 23.2. In the year 2005, what is the difference between the Unemployed and educated labor force (% of population) in OECD members and Unemployed and educated labor force (% of population) in Bahrain?
Provide a short and direct response. -3.61. In the year 2005, what is the difference between the Unemployed and educated labor force (% of population) of OECD members and Unemployed and educated labor force (% of population) of Georgia?
Offer a very short reply. -15.91. In the year 2005, what is the difference between the Unemployed and educated labor force (% of population) of OECD members and Unemployed and educated labor force (% of population) of Kuwait?
Your answer should be compact. 9.89. In the year 2005, what is the difference between the Unemployed and educated labor force (% of population) in Bahrain and Unemployed and educated labor force (% of population) in Georgia?
Provide a succinct answer. -12.3. In the year 2005, what is the difference between the Unemployed and educated labor force (% of population) of Georgia and Unemployed and educated labor force (% of population) of Kuwait?
Keep it short and to the point. 25.8. In the year 2006, what is the difference between the Unemployed and educated labor force (% of population) in OECD members and Unemployed and educated labor force (% of population) in Bahrain?
Make the answer very short. -12.36. In the year 2006, what is the difference between the Unemployed and educated labor force (% of population) in OECD members and Unemployed and educated labor force (% of population) in Georgia?
Make the answer very short. -16.86. In the year 2006, what is the difference between the Unemployed and educated labor force (% of population) in OECD members and Unemployed and educated labor force (% of population) in Kuwait?
Offer a very short reply. 13.44. In the year 2006, what is the difference between the Unemployed and educated labor force (% of population) of Bahrain and Unemployed and educated labor force (% of population) of Georgia?
Make the answer very short. -4.5. In the year 2006, what is the difference between the Unemployed and educated labor force (% of population) of Bahrain and Unemployed and educated labor force (% of population) of Kuwait?
Ensure brevity in your answer.  25.8. In the year 2006, what is the difference between the Unemployed and educated labor force (% of population) in Georgia and Unemployed and educated labor force (% of population) in Kuwait?
Give a very brief answer. 30.3. What is the ratio of the Unemployed and educated labor force (% of population) in OECD members in 1998 to that in 1999?
Provide a succinct answer. 0.97. What is the ratio of the Unemployed and educated labor force (% of population) of Bahrain in 1998 to that in 1999?
Offer a terse response. 0.97. What is the ratio of the Unemployed and educated labor force (% of population) of Georgia in 1998 to that in 1999?
Offer a terse response. 0.85. What is the ratio of the Unemployed and educated labor force (% of population) of OECD members in 1998 to that in 2000?
Offer a very short reply. 0.98. What is the ratio of the Unemployed and educated labor force (% of population) of Bahrain in 1998 to that in 2000?
Offer a terse response. 0.99. What is the ratio of the Unemployed and educated labor force (% of population) in Georgia in 1998 to that in 2000?
Your answer should be very brief. 0.92. What is the ratio of the Unemployed and educated labor force (% of population) in Kuwait in 1998 to that in 2000?
Make the answer very short. 1.12. What is the ratio of the Unemployed and educated labor force (% of population) of OECD members in 1998 to that in 2002?
Keep it short and to the point. 0.81. What is the ratio of the Unemployed and educated labor force (% of population) of Bahrain in 1998 to that in 2002?
Offer a terse response. 1.19. What is the ratio of the Unemployed and educated labor force (% of population) of Georgia in 1998 to that in 2002?
Ensure brevity in your answer.  0.83. What is the ratio of the Unemployed and educated labor force (% of population) in Kuwait in 1998 to that in 2002?
Your response must be concise. 0.46. What is the ratio of the Unemployed and educated labor force (% of population) of OECD members in 1998 to that in 2003?
Keep it short and to the point. 0.78. What is the ratio of the Unemployed and educated labor force (% of population) in Bahrain in 1998 to that in 2003?
Your response must be concise. 1.24. What is the ratio of the Unemployed and educated labor force (% of population) in Georgia in 1998 to that in 2003?
Keep it short and to the point. 0.78. What is the ratio of the Unemployed and educated labor force (% of population) in Kuwait in 1998 to that in 2003?
Provide a short and direct response. 0.19. What is the ratio of the Unemployed and educated labor force (% of population) of OECD members in 1998 to that in 2004?
Make the answer very short. 0.79. What is the ratio of the Unemployed and educated labor force (% of population) in Bahrain in 1998 to that in 2004?
Make the answer very short. 0.97. What is the ratio of the Unemployed and educated labor force (% of population) of Georgia in 1998 to that in 2004?
Make the answer very short. 0.83. What is the ratio of the Unemployed and educated labor force (% of population) of Kuwait in 1998 to that in 2004?
Give a very brief answer. 0.21. What is the ratio of the Unemployed and educated labor force (% of population) in OECD members in 1998 to that in 2005?
Offer a terse response. 0.8. What is the ratio of the Unemployed and educated labor force (% of population) in Bahrain in 1998 to that in 2005?
Provide a succinct answer. 0.73. What is the ratio of the Unemployed and educated labor force (% of population) in Georgia in 1998 to that in 2005?
Make the answer very short. 0.78. What is the ratio of the Unemployed and educated labor force (% of population) of Kuwait in 1998 to that in 2005?
Offer a very short reply. 0.22. What is the ratio of the Unemployed and educated labor force (% of population) in OECD members in 1998 to that in 2006?
Your answer should be compact. 0.79. What is the ratio of the Unemployed and educated labor force (% of population) of Bahrain in 1998 to that in 2006?
Give a very brief answer. 0.55. What is the ratio of the Unemployed and educated labor force (% of population) of Georgia in 1998 to that in 2006?
Provide a succinct answer. 0.76. What is the ratio of the Unemployed and educated labor force (% of population) of Kuwait in 1998 to that in 2006?
Your response must be concise. 0.29. What is the ratio of the Unemployed and educated labor force (% of population) in OECD members in 1999 to that in 2000?
Offer a terse response. 1.01. What is the ratio of the Unemployed and educated labor force (% of population) in Bahrain in 1999 to that in 2000?
Your answer should be very brief. 1.03. What is the ratio of the Unemployed and educated labor force (% of population) of Georgia in 1999 to that in 2000?
Make the answer very short. 1.07. What is the ratio of the Unemployed and educated labor force (% of population) in Kuwait in 1999 to that in 2000?
Offer a terse response. 1.12. What is the ratio of the Unemployed and educated labor force (% of population) of OECD members in 1999 to that in 2002?
Give a very brief answer. 0.84. What is the ratio of the Unemployed and educated labor force (% of population) in Bahrain in 1999 to that in 2002?
Your response must be concise. 1.23. What is the ratio of the Unemployed and educated labor force (% of population) in Kuwait in 1999 to that in 2002?
Your answer should be very brief. 0.46. What is the ratio of the Unemployed and educated labor force (% of population) in OECD members in 1999 to that in 2003?
Provide a short and direct response. 0.81. What is the ratio of the Unemployed and educated labor force (% of population) of Bahrain in 1999 to that in 2003?
Offer a terse response. 1.29. What is the ratio of the Unemployed and educated labor force (% of population) of Georgia in 1999 to that in 2003?
Keep it short and to the point. 0.92. What is the ratio of the Unemployed and educated labor force (% of population) of Kuwait in 1999 to that in 2003?
Your response must be concise. 0.19. What is the ratio of the Unemployed and educated labor force (% of population) of OECD members in 1999 to that in 2004?
Your response must be concise. 0.82. What is the ratio of the Unemployed and educated labor force (% of population) of Bahrain in 1999 to that in 2004?
Offer a terse response. 1.01. What is the ratio of the Unemployed and educated labor force (% of population) of Georgia in 1999 to that in 2004?
Offer a very short reply. 0.97. What is the ratio of the Unemployed and educated labor force (% of population) in Kuwait in 1999 to that in 2004?
Offer a terse response. 0.21. What is the ratio of the Unemployed and educated labor force (% of population) in OECD members in 1999 to that in 2005?
Your answer should be very brief. 0.83. What is the ratio of the Unemployed and educated labor force (% of population) of Bahrain in 1999 to that in 2005?
Your answer should be very brief. 0.76. What is the ratio of the Unemployed and educated labor force (% of population) of Georgia in 1999 to that in 2005?
Offer a very short reply. 0.91. What is the ratio of the Unemployed and educated labor force (% of population) of Kuwait in 1999 to that in 2005?
Ensure brevity in your answer.  0.22. What is the ratio of the Unemployed and educated labor force (% of population) of OECD members in 1999 to that in 2006?
Your response must be concise. 0.82. What is the ratio of the Unemployed and educated labor force (% of population) of Bahrain in 1999 to that in 2006?
Your answer should be very brief. 0.57. What is the ratio of the Unemployed and educated labor force (% of population) of Georgia in 1999 to that in 2006?
Give a very brief answer. 0.89. What is the ratio of the Unemployed and educated labor force (% of population) in Kuwait in 1999 to that in 2006?
Offer a very short reply. 0.29. What is the ratio of the Unemployed and educated labor force (% of population) in OECD members in 2000 to that in 2002?
Give a very brief answer. 0.83. What is the ratio of the Unemployed and educated labor force (% of population) in Bahrain in 2000 to that in 2002?
Provide a succinct answer. 1.2. What is the ratio of the Unemployed and educated labor force (% of population) of Georgia in 2000 to that in 2002?
Offer a very short reply. 0.91. What is the ratio of the Unemployed and educated labor force (% of population) of Kuwait in 2000 to that in 2002?
Offer a terse response. 0.41. What is the ratio of the Unemployed and educated labor force (% of population) in OECD members in 2000 to that in 2003?
Keep it short and to the point. 0.8. What is the ratio of the Unemployed and educated labor force (% of population) in Georgia in 2000 to that in 2003?
Your answer should be very brief. 0.86. What is the ratio of the Unemployed and educated labor force (% of population) of Kuwait in 2000 to that in 2003?
Ensure brevity in your answer.  0.17. What is the ratio of the Unemployed and educated labor force (% of population) in OECD members in 2000 to that in 2004?
Ensure brevity in your answer.  0.81. What is the ratio of the Unemployed and educated labor force (% of population) of Bahrain in 2000 to that in 2004?
Provide a short and direct response. 0.98. What is the ratio of the Unemployed and educated labor force (% of population) in Georgia in 2000 to that in 2004?
Keep it short and to the point. 0.91. What is the ratio of the Unemployed and educated labor force (% of population) in Kuwait in 2000 to that in 2004?
Ensure brevity in your answer.  0.19. What is the ratio of the Unemployed and educated labor force (% of population) in OECD members in 2000 to that in 2005?
Your answer should be very brief. 0.82. What is the ratio of the Unemployed and educated labor force (% of population) of Bahrain in 2000 to that in 2005?
Offer a terse response. 0.74. What is the ratio of the Unemployed and educated labor force (% of population) in Georgia in 2000 to that in 2005?
Provide a succinct answer. 0.85. What is the ratio of the Unemployed and educated labor force (% of population) of Kuwait in 2000 to that in 2005?
Make the answer very short. 0.19. What is the ratio of the Unemployed and educated labor force (% of population) in OECD members in 2000 to that in 2006?
Ensure brevity in your answer.  0.81. What is the ratio of the Unemployed and educated labor force (% of population) of Bahrain in 2000 to that in 2006?
Your answer should be compact. 0.55. What is the ratio of the Unemployed and educated labor force (% of population) in Georgia in 2000 to that in 2006?
Provide a short and direct response. 0.83. What is the ratio of the Unemployed and educated labor force (% of population) in Kuwait in 2000 to that in 2006?
Ensure brevity in your answer.  0.26. What is the ratio of the Unemployed and educated labor force (% of population) of OECD members in 2002 to that in 2003?
Keep it short and to the point. 0.96. What is the ratio of the Unemployed and educated labor force (% of population) of Bahrain in 2002 to that in 2003?
Keep it short and to the point. 1.04. What is the ratio of the Unemployed and educated labor force (% of population) of Georgia in 2002 to that in 2003?
Your answer should be very brief. 0.94. What is the ratio of the Unemployed and educated labor force (% of population) in Kuwait in 2002 to that in 2003?
Offer a very short reply. 0.42. What is the ratio of the Unemployed and educated labor force (% of population) of OECD members in 2002 to that in 2004?
Provide a short and direct response. 0.97. What is the ratio of the Unemployed and educated labor force (% of population) of Bahrain in 2002 to that in 2004?
Ensure brevity in your answer.  0.82. What is the ratio of the Unemployed and educated labor force (% of population) of Kuwait in 2002 to that in 2004?
Your response must be concise. 0.46. What is the ratio of the Unemployed and educated labor force (% of population) in OECD members in 2002 to that in 2005?
Give a very brief answer. 0.98. What is the ratio of the Unemployed and educated labor force (% of population) in Bahrain in 2002 to that in 2005?
Provide a succinct answer. 0.62. What is the ratio of the Unemployed and educated labor force (% of population) of Georgia in 2002 to that in 2005?
Provide a short and direct response. 0.94. What is the ratio of the Unemployed and educated labor force (% of population) of Kuwait in 2002 to that in 2005?
Give a very brief answer. 0.47. What is the ratio of the Unemployed and educated labor force (% of population) in OECD members in 2002 to that in 2006?
Your answer should be very brief. 0.98. What is the ratio of the Unemployed and educated labor force (% of population) of Bahrain in 2002 to that in 2006?
Ensure brevity in your answer.  0.46. What is the ratio of the Unemployed and educated labor force (% of population) of Georgia in 2002 to that in 2006?
Your response must be concise. 0.91. What is the ratio of the Unemployed and educated labor force (% of population) in Kuwait in 2002 to that in 2006?
Give a very brief answer. 0.64. What is the ratio of the Unemployed and educated labor force (% of population) in OECD members in 2003 to that in 2004?
Your answer should be very brief. 1.01. What is the ratio of the Unemployed and educated labor force (% of population) of Bahrain in 2003 to that in 2004?
Provide a short and direct response. 0.78. What is the ratio of the Unemployed and educated labor force (% of population) of Georgia in 2003 to that in 2004?
Make the answer very short. 1.06. What is the ratio of the Unemployed and educated labor force (% of population) in Kuwait in 2003 to that in 2004?
Your response must be concise. 1.09. What is the ratio of the Unemployed and educated labor force (% of population) of OECD members in 2003 to that in 2005?
Your answer should be compact. 1.02. What is the ratio of the Unemployed and educated labor force (% of population) in Bahrain in 2003 to that in 2005?
Your answer should be compact. 0.59. What is the ratio of the Unemployed and educated labor force (% of population) of Georgia in 2003 to that in 2005?
Ensure brevity in your answer.  1. What is the ratio of the Unemployed and educated labor force (% of population) in Kuwait in 2003 to that in 2005?
Keep it short and to the point. 1.12. What is the ratio of the Unemployed and educated labor force (% of population) in OECD members in 2003 to that in 2006?
Offer a terse response. 1.02. What is the ratio of the Unemployed and educated labor force (% of population) in Bahrain in 2003 to that in 2006?
Provide a short and direct response. 0.44. What is the ratio of the Unemployed and educated labor force (% of population) of Georgia in 2003 to that in 2006?
Provide a short and direct response. 0.97. What is the ratio of the Unemployed and educated labor force (% of population) in Kuwait in 2003 to that in 2006?
Ensure brevity in your answer.  1.51. What is the ratio of the Unemployed and educated labor force (% of population) of OECD members in 2004 to that in 2005?
Your response must be concise. 1.01. What is the ratio of the Unemployed and educated labor force (% of population) of Bahrain in 2004 to that in 2005?
Ensure brevity in your answer.  0.75. What is the ratio of the Unemployed and educated labor force (% of population) in Georgia in 2004 to that in 2005?
Offer a very short reply. 0.94. What is the ratio of the Unemployed and educated labor force (% of population) in Kuwait in 2004 to that in 2005?
Offer a terse response. 1.02. What is the ratio of the Unemployed and educated labor force (% of population) of OECD members in 2004 to that in 2006?
Offer a very short reply. 1. What is the ratio of the Unemployed and educated labor force (% of population) of Bahrain in 2004 to that in 2006?
Keep it short and to the point. 0.56. What is the ratio of the Unemployed and educated labor force (% of population) in Georgia in 2004 to that in 2006?
Give a very brief answer. 0.91. What is the ratio of the Unemployed and educated labor force (% of population) of Kuwait in 2004 to that in 2006?
Provide a short and direct response. 1.39. What is the ratio of the Unemployed and educated labor force (% of population) of Bahrain in 2005 to that in 2006?
Offer a very short reply. 0.75. What is the ratio of the Unemployed and educated labor force (% of population) in Georgia in 2005 to that in 2006?
Ensure brevity in your answer.  0.97. What is the ratio of the Unemployed and educated labor force (% of population) in Kuwait in 2005 to that in 2006?
Offer a terse response. 1.35. What is the difference between the highest and the second highest Unemployed and educated labor force (% of population) of OECD members?
Provide a short and direct response. 0.26. What is the difference between the highest and the lowest Unemployed and educated labor force (% of population) of OECD members?
Give a very brief answer. 5.16. What is the difference between the highest and the lowest Unemployed and educated labor force (% of population) in Bahrain?
Keep it short and to the point. 19.8. What is the difference between the highest and the lowest Unemployed and educated labor force (% of population) of Georgia?
Your response must be concise. 9.6. 